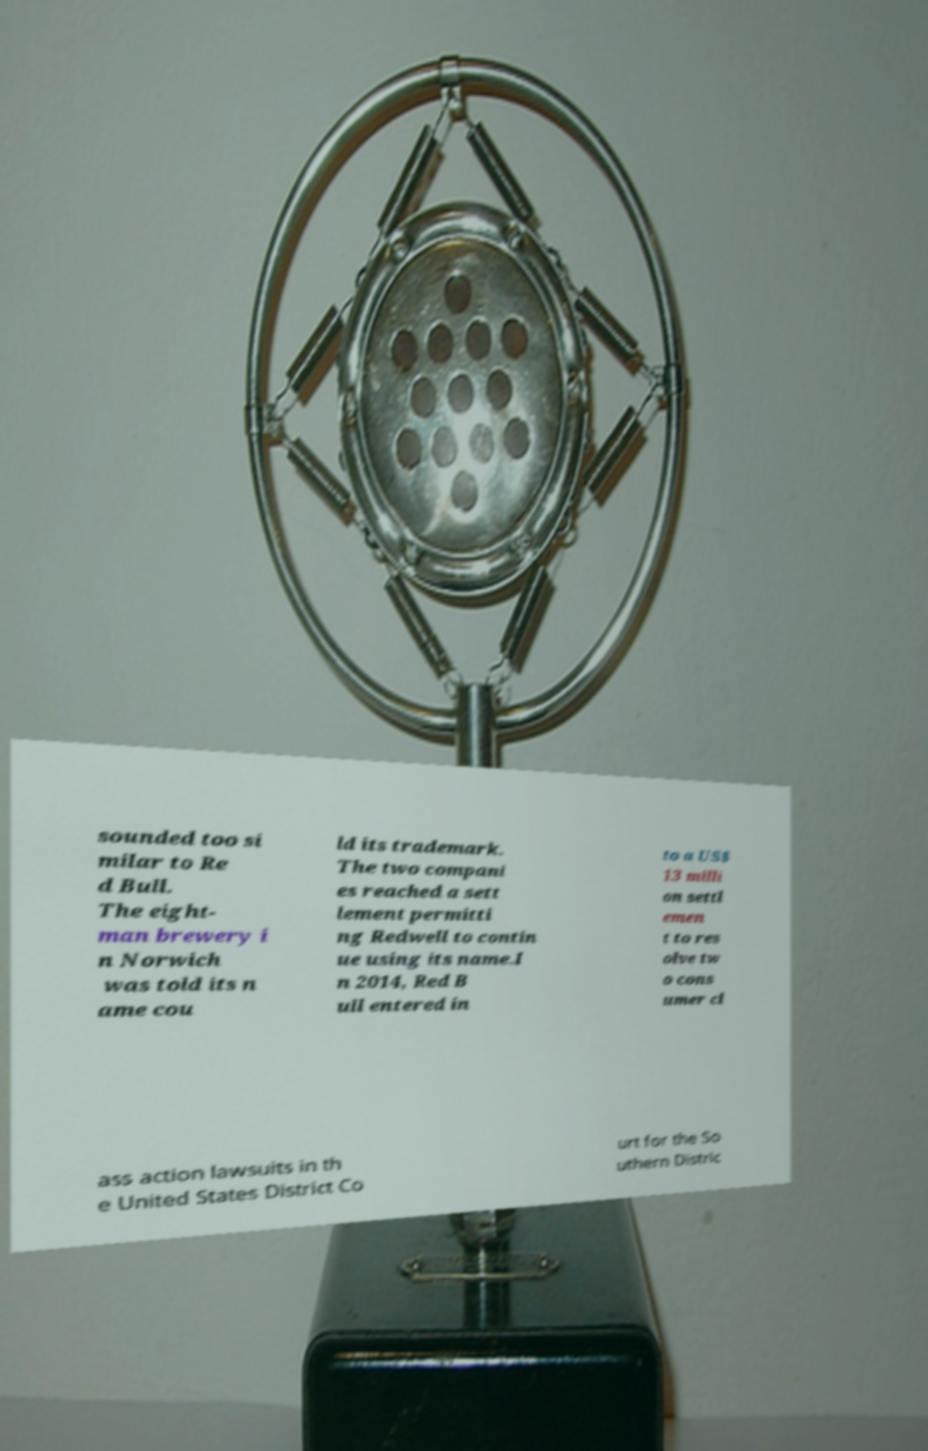I need the written content from this picture converted into text. Can you do that? sounded too si milar to Re d Bull. The eight- man brewery i n Norwich was told its n ame cou ld its trademark. The two compani es reached a sett lement permitti ng Redwell to contin ue using its name.I n 2014, Red B ull entered in to a US$ 13 milli on settl emen t to res olve tw o cons umer cl ass action lawsuits in th e United States District Co urt for the So uthern Distric 